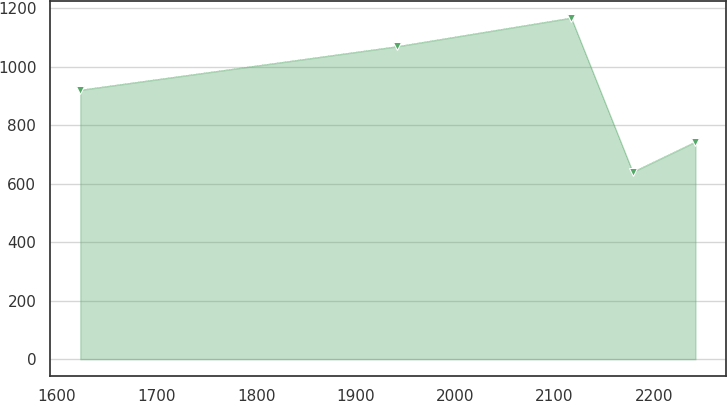Convert chart to OTSL. <chart><loc_0><loc_0><loc_500><loc_500><line_chart><ecel><fcel>Unnamed: 1<nl><fcel>1623.34<fcel>920.75<nl><fcel>1941.6<fcel>1069.59<nl><fcel>2116.69<fcel>1167.37<nl><fcel>2178.51<fcel>640.27<nl><fcel>2241.55<fcel>743.51<nl></chart> 